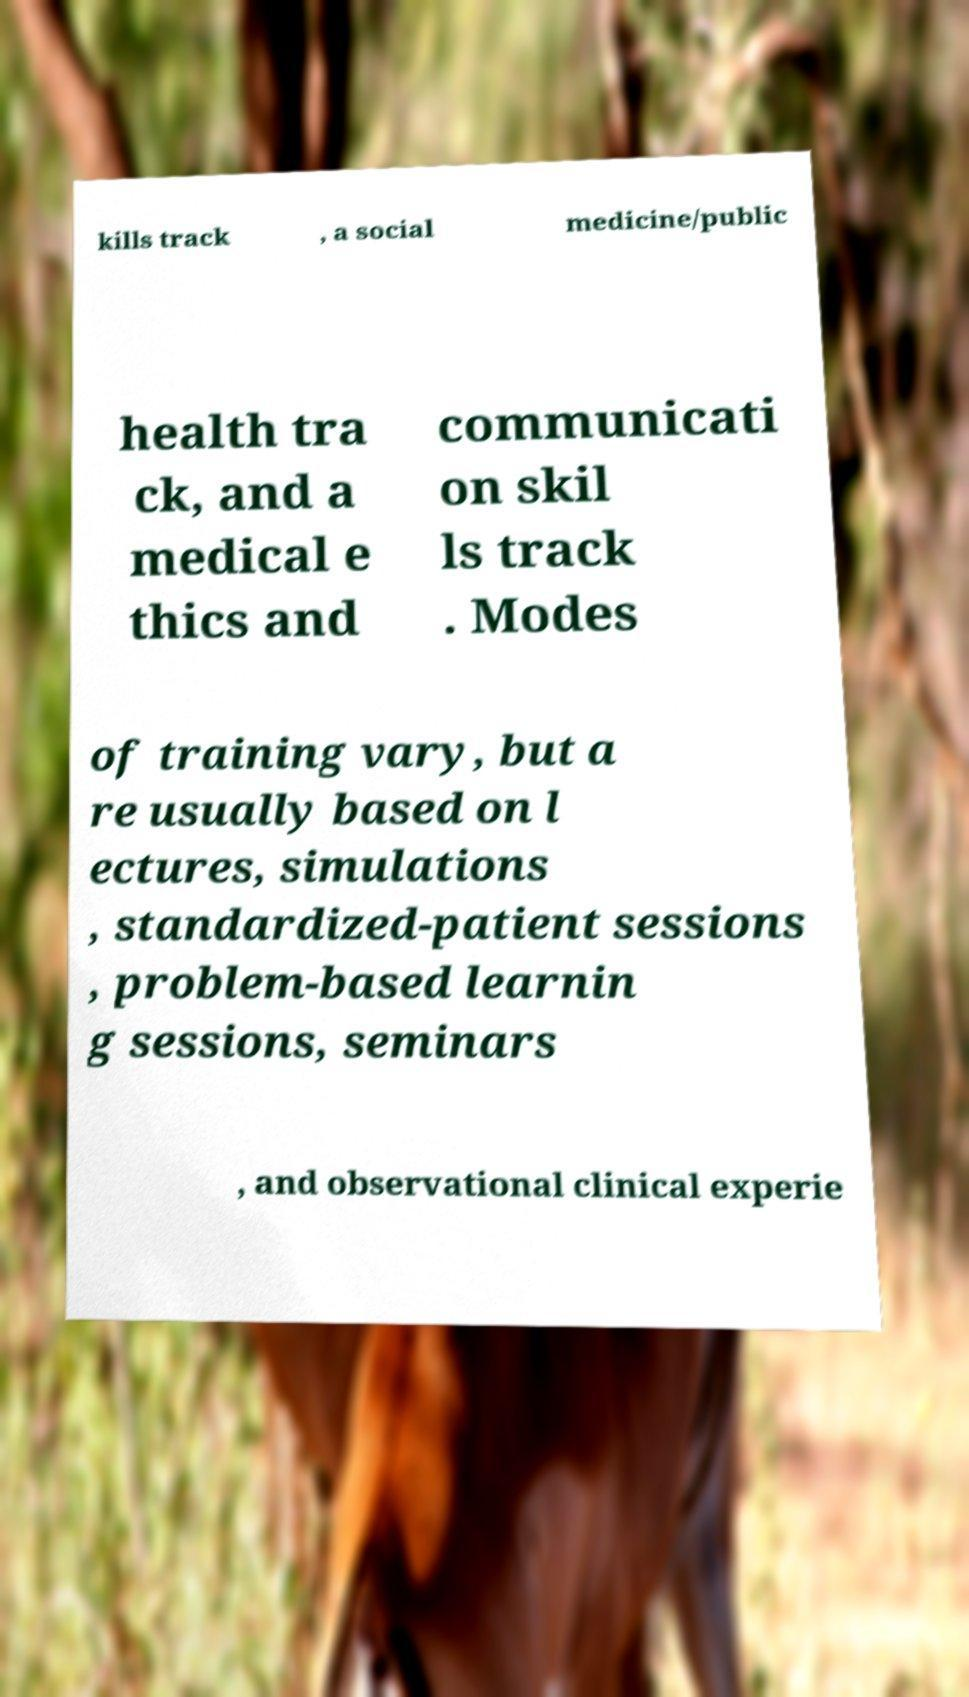Can you read and provide the text displayed in the image?This photo seems to have some interesting text. Can you extract and type it out for me? kills track , a social medicine/public health tra ck, and a medical e thics and communicati on skil ls track . Modes of training vary, but a re usually based on l ectures, simulations , standardized-patient sessions , problem-based learnin g sessions, seminars , and observational clinical experie 